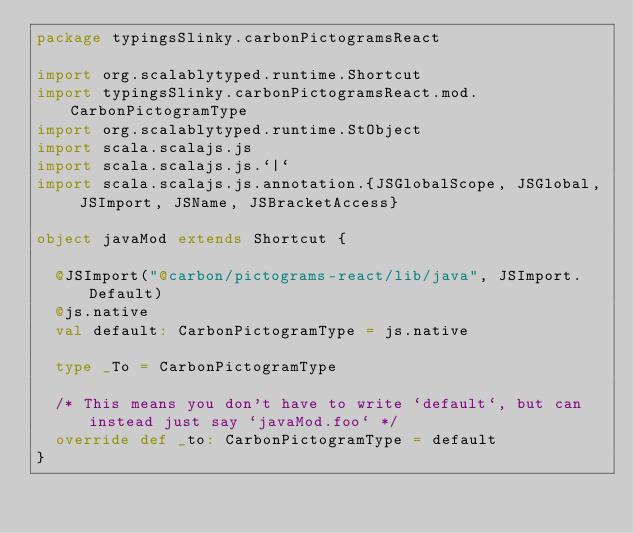<code> <loc_0><loc_0><loc_500><loc_500><_Scala_>package typingsSlinky.carbonPictogramsReact

import org.scalablytyped.runtime.Shortcut
import typingsSlinky.carbonPictogramsReact.mod.CarbonPictogramType
import org.scalablytyped.runtime.StObject
import scala.scalajs.js
import scala.scalajs.js.`|`
import scala.scalajs.js.annotation.{JSGlobalScope, JSGlobal, JSImport, JSName, JSBracketAccess}

object javaMod extends Shortcut {
  
  @JSImport("@carbon/pictograms-react/lib/java", JSImport.Default)
  @js.native
  val default: CarbonPictogramType = js.native
  
  type _To = CarbonPictogramType
  
  /* This means you don't have to write `default`, but can instead just say `javaMod.foo` */
  override def _to: CarbonPictogramType = default
}
</code> 